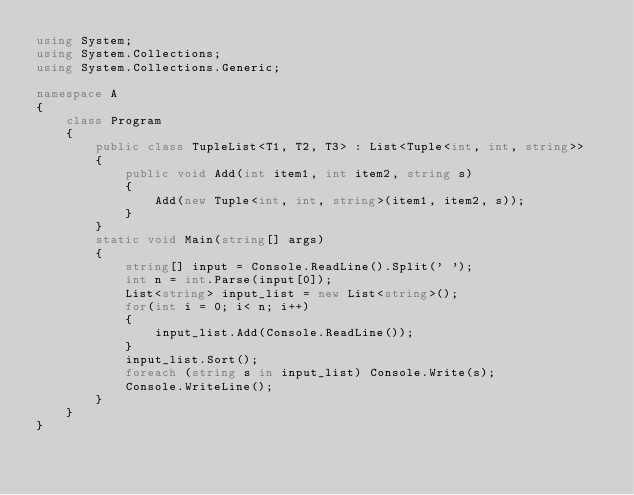Convert code to text. <code><loc_0><loc_0><loc_500><loc_500><_C#_>using System;
using System.Collections;
using System.Collections.Generic;

namespace A
{
    class Program
    {
        public class TupleList<T1, T2, T3> : List<Tuple<int, int, string>>
        {
            public void Add(int item1, int item2, string s)
            {
                Add(new Tuple<int, int, string>(item1, item2, s));
            }
        }
        static void Main(string[] args)
        {
            string[] input = Console.ReadLine().Split(' ');
            int n = int.Parse(input[0]);
            List<string> input_list = new List<string>();
            for(int i = 0; i< n; i++)
            {
                input_list.Add(Console.ReadLine());
            }
            input_list.Sort();
            foreach (string s in input_list) Console.Write(s);
            Console.WriteLine();
        }
    }
}
</code> 